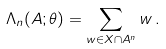<formula> <loc_0><loc_0><loc_500><loc_500>\Lambda _ { n } ( A ; \theta ) = \sum _ { w \in X \cap A ^ { n } } w \, .</formula> 